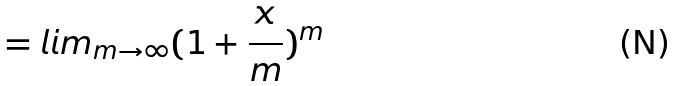Convert formula to latex. <formula><loc_0><loc_0><loc_500><loc_500>= l i m _ { m \rightarrow \infty } ( 1 + \frac { x } { m } ) ^ { m }</formula> 